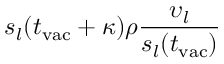<formula> <loc_0><loc_0><loc_500><loc_500>s _ { l } ( t _ { v a c } + \kappa ) \rho \frac { \upsilon _ { l } } { s _ { l } ( t _ { v a c } ) }</formula> 